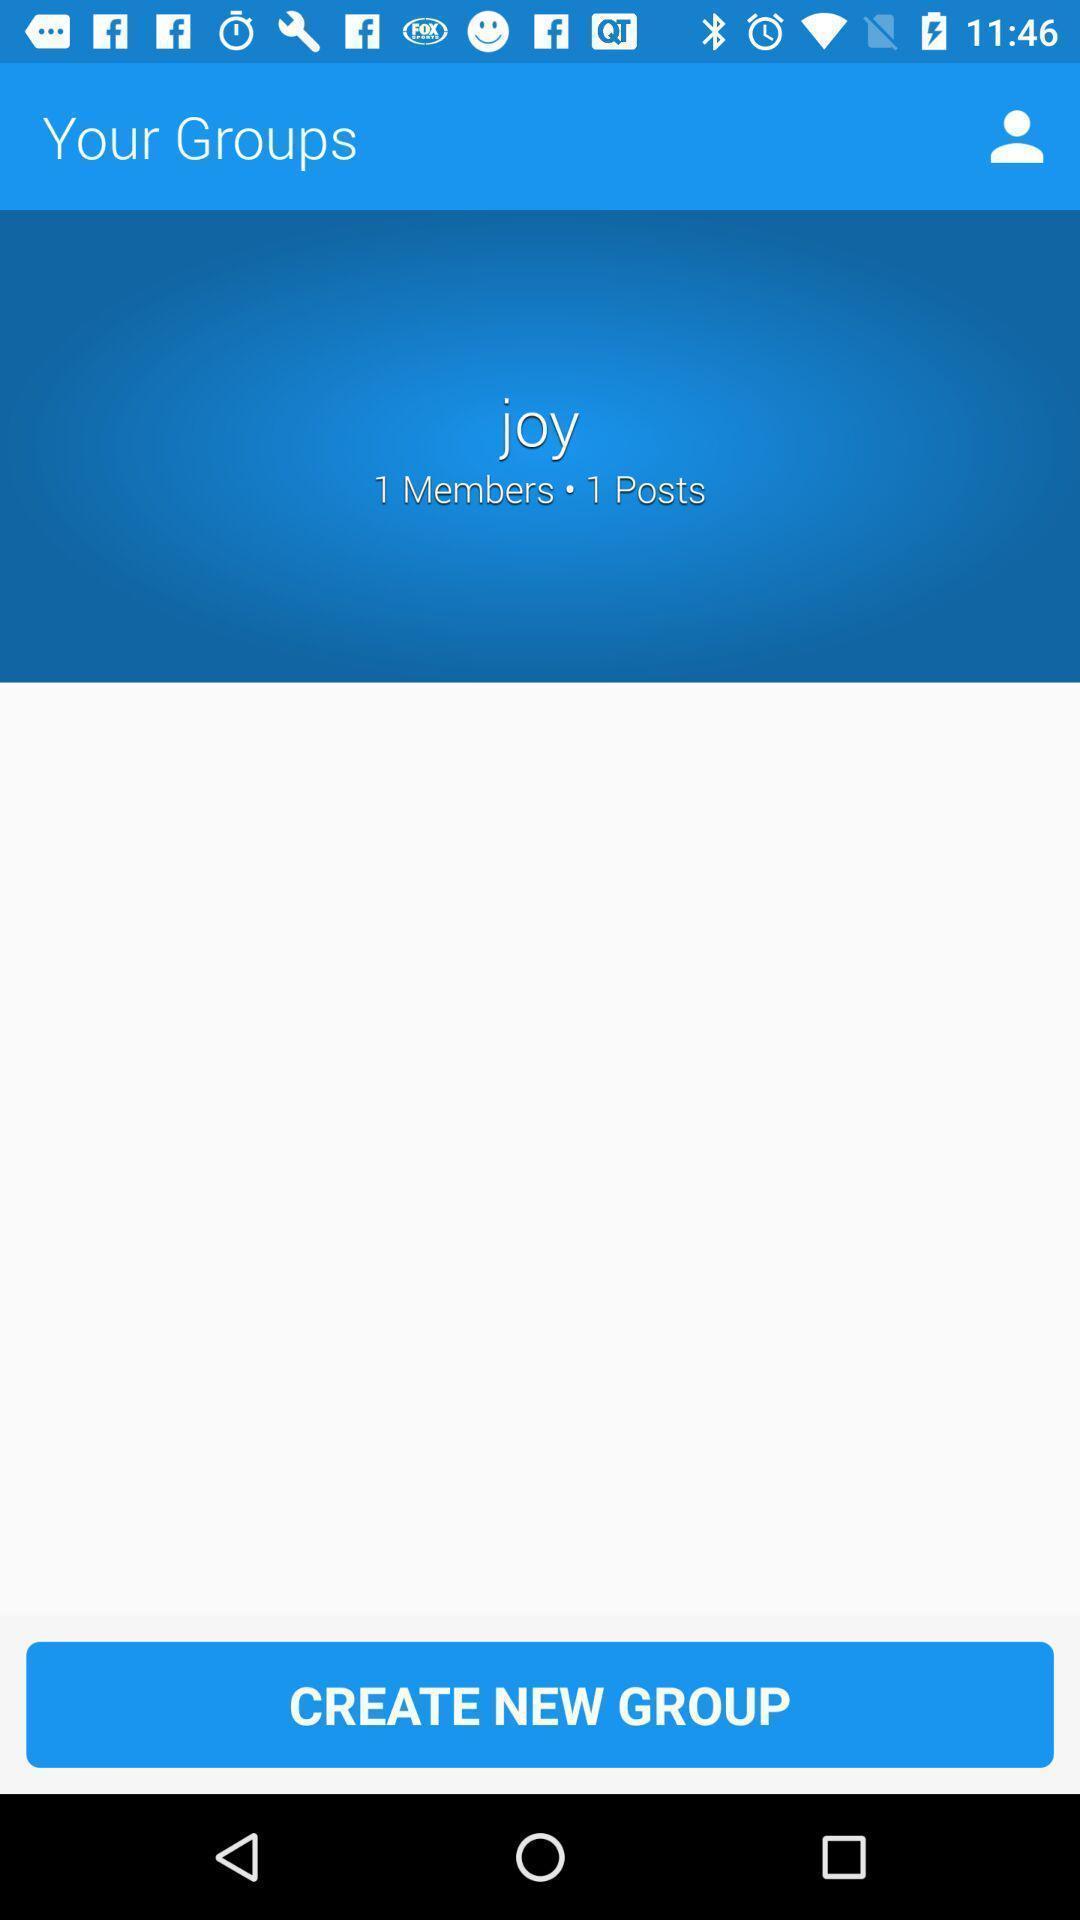Tell me about the visual elements in this screen capture. Screen displaying the page to create new group. 